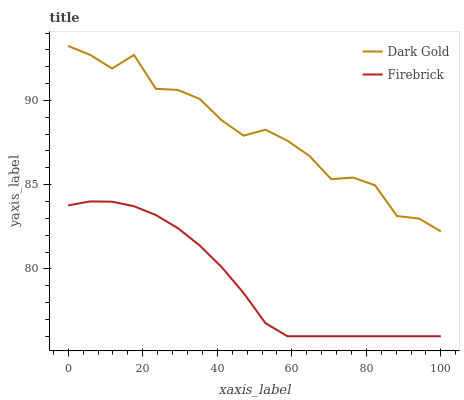Does Firebrick have the minimum area under the curve?
Answer yes or no. Yes. Does Dark Gold have the maximum area under the curve?
Answer yes or no. Yes. Does Dark Gold have the minimum area under the curve?
Answer yes or no. No. Is Firebrick the smoothest?
Answer yes or no. Yes. Is Dark Gold the roughest?
Answer yes or no. Yes. Is Dark Gold the smoothest?
Answer yes or no. No. Does Firebrick have the lowest value?
Answer yes or no. Yes. Does Dark Gold have the lowest value?
Answer yes or no. No. Does Dark Gold have the highest value?
Answer yes or no. Yes. Is Firebrick less than Dark Gold?
Answer yes or no. Yes. Is Dark Gold greater than Firebrick?
Answer yes or no. Yes. Does Firebrick intersect Dark Gold?
Answer yes or no. No. 